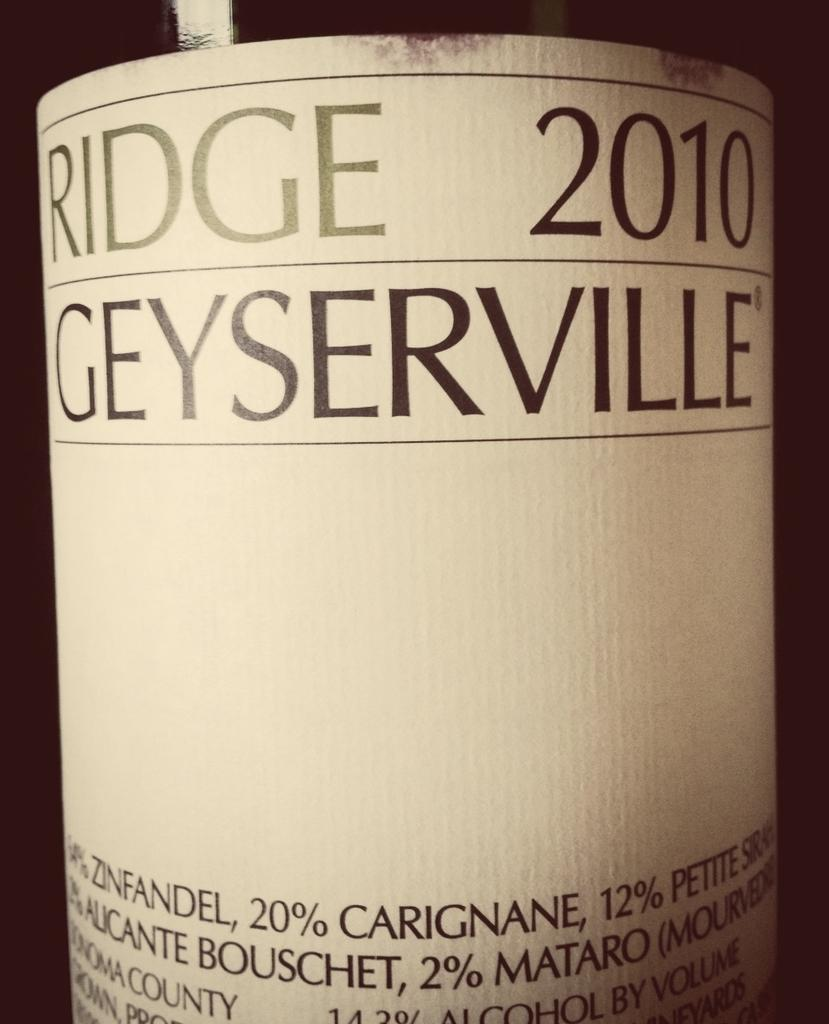Provide a one-sentence caption for the provided image. Ridge 2010 Geyserville alcohol bottle that is in a picture. 